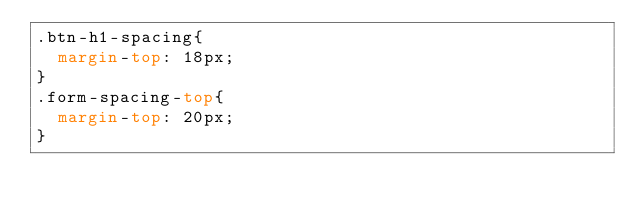<code> <loc_0><loc_0><loc_500><loc_500><_CSS_>.btn-h1-spacing{
	margin-top: 18px;
}
.form-spacing-top{
	margin-top: 20px;
}</code> 